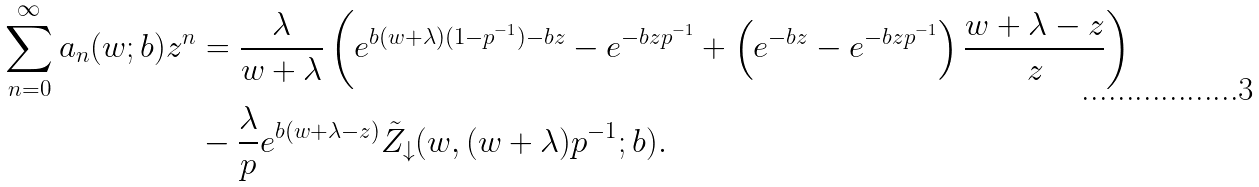Convert formula to latex. <formula><loc_0><loc_0><loc_500><loc_500>\sum _ { n = 0 } ^ { \infty } a _ { n } ( w ; b ) z ^ { n } & = \frac { \lambda } { w + \lambda } \left ( e ^ { b ( w + \lambda ) ( 1 - p ^ { - 1 } ) - b z } - e ^ { - b z p ^ { - 1 } } + \left ( e ^ { - b z } - e ^ { - b z p ^ { - 1 } } \right ) \frac { w + \lambda - z } { z } \right ) \\ & - \frac { \lambda } { p } e ^ { b ( w + \lambda - z ) } \tilde { Z } _ { \downarrow } ( w , ( w + \lambda ) p ^ { - 1 } ; b ) .</formula> 